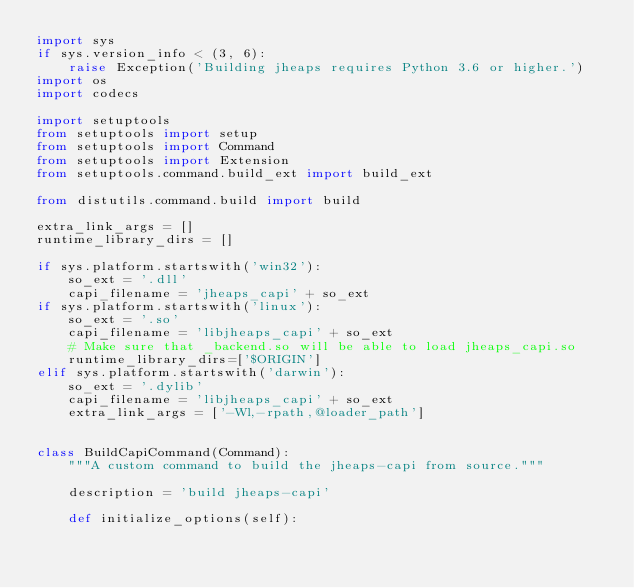<code> <loc_0><loc_0><loc_500><loc_500><_Python_>import sys
if sys.version_info < (3, 6):
    raise Exception('Building jheaps requires Python 3.6 or higher.')
import os
import codecs

import setuptools
from setuptools import setup
from setuptools import Command
from setuptools import Extension
from setuptools.command.build_ext import build_ext

from distutils.command.build import build

extra_link_args = []
runtime_library_dirs = []

if sys.platform.startswith('win32'):
    so_ext = '.dll'
    capi_filename = 'jheaps_capi' + so_ext
if sys.platform.startswith('linux'):
    so_ext = '.so'
    capi_filename = 'libjheaps_capi' + so_ext
    # Make sure that _backend.so will be able to load jheaps_capi.so
    runtime_library_dirs=['$ORIGIN']
elif sys.platform.startswith('darwin'):
    so_ext = '.dylib'
    capi_filename = 'libjheaps_capi' + so_ext
    extra_link_args = ['-Wl,-rpath,@loader_path']


class BuildCapiCommand(Command):
    """A custom command to build the jheaps-capi from source."""

    description = 'build jheaps-capi'

    def initialize_options(self):</code> 